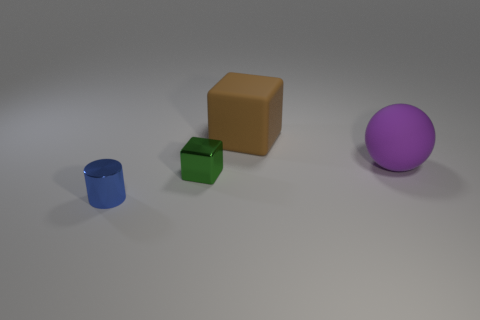Add 3 yellow metallic blocks. How many objects exist? 7 Subtract all cylinders. How many objects are left? 3 Subtract all rubber things. Subtract all purple matte balls. How many objects are left? 1 Add 1 big purple matte balls. How many big purple matte balls are left? 2 Add 3 small gray rubber things. How many small gray rubber things exist? 3 Subtract 0 red cylinders. How many objects are left? 4 